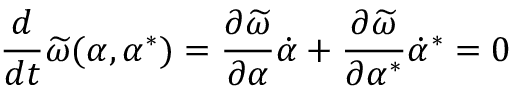Convert formula to latex. <formula><loc_0><loc_0><loc_500><loc_500>\frac { d } { d t } \widetilde { \omega } ( \alpha , \alpha ^ { * } ) = \frac { \partial \widetilde { \omega } } { \partial \alpha } \dot { \alpha } + \frac { \partial \widetilde { \omega } } { \partial \alpha ^ { * } } \dot { \alpha } ^ { * } = 0</formula> 